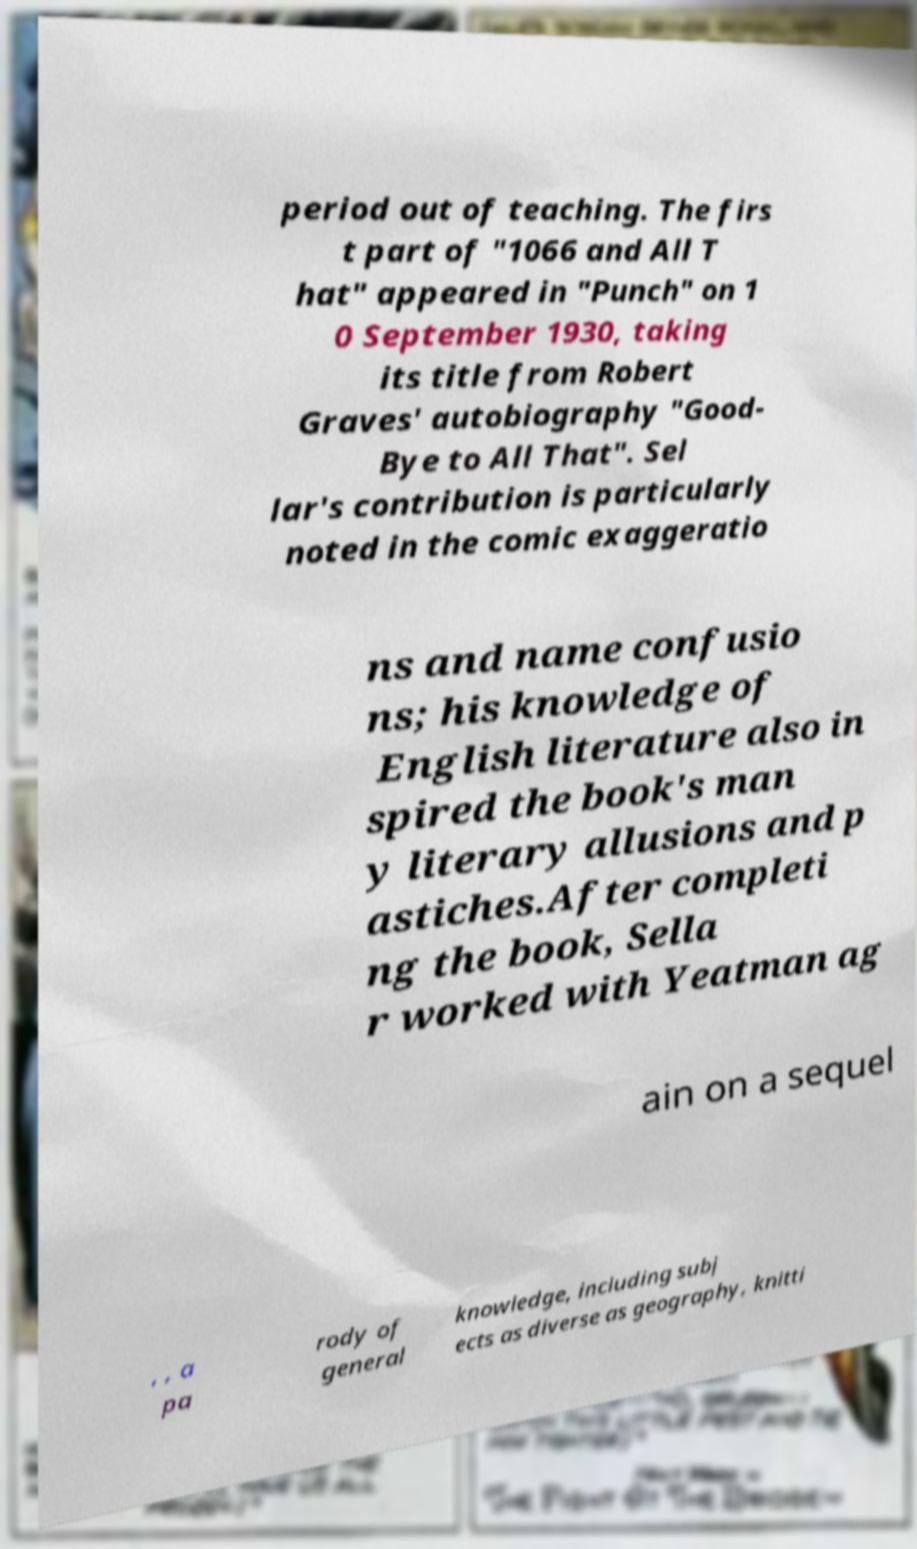Could you assist in decoding the text presented in this image and type it out clearly? period out of teaching. The firs t part of "1066 and All T hat" appeared in "Punch" on 1 0 September 1930, taking its title from Robert Graves' autobiography "Good- Bye to All That". Sel lar's contribution is particularly noted in the comic exaggeratio ns and name confusio ns; his knowledge of English literature also in spired the book's man y literary allusions and p astiches.After completi ng the book, Sella r worked with Yeatman ag ain on a sequel , , a pa rody of general knowledge, including subj ects as diverse as geography, knitti 